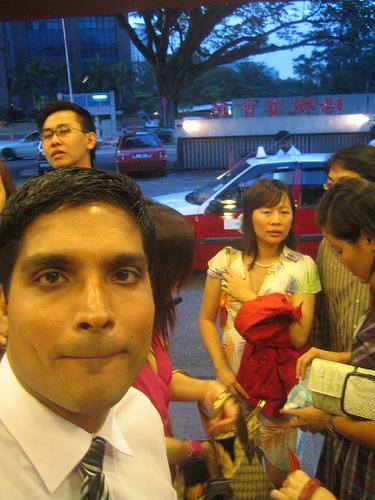What nationality does the man in the foreground appear to be? indian 